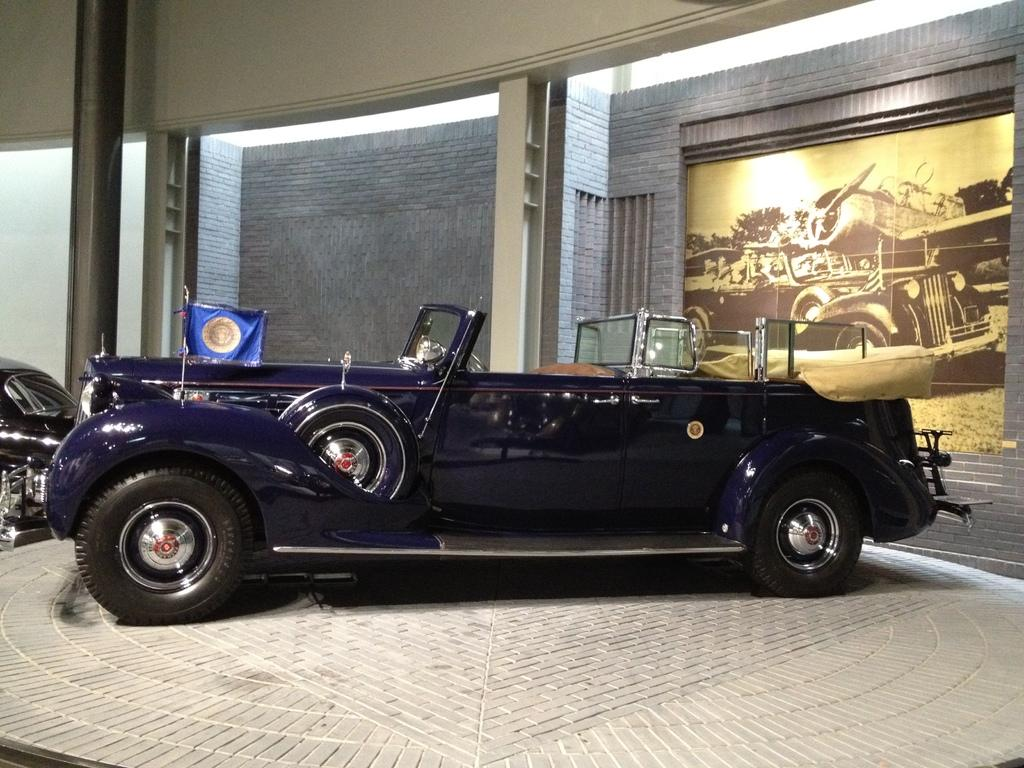What is the main subject of the image? There is a dark blue color car in the center of the image. What can be seen in the background of the image? There is a wall, pillars, a screen, a flag, and a black color car in the background of the image. Can you describe the objects visible in the background? There are pillars, a screen, a flag, and a black color car in the background of the image. How many cars are visible in the image? There are two cars visible in the image, a dark blue color car in the center and a black color car in the background. What type of knowledge can be gained from the oil in the image? There is no oil present in the image, so no knowledge can be gained from it. 